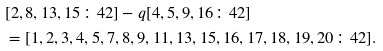<formula> <loc_0><loc_0><loc_500><loc_500>& [ 2 , 8 , 1 3 , 1 5 \colon 4 2 ] - q [ 4 , 5 , 9 , 1 6 \colon 4 2 ] \\ & = [ 1 , 2 , 3 , 4 , 5 , 7 , 8 , 9 , 1 1 , 1 3 , 1 5 , 1 6 , 1 7 , 1 8 , 1 9 , 2 0 \colon 4 2 ] .</formula> 